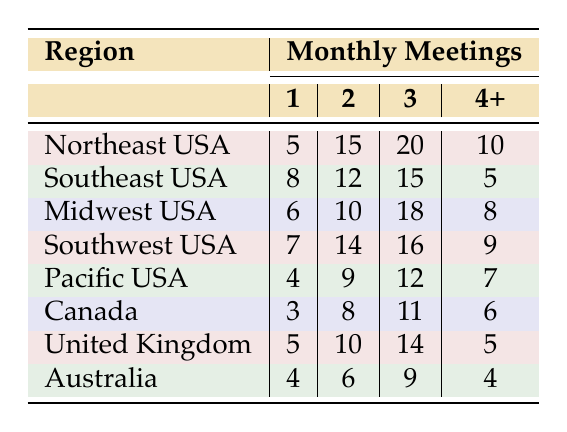What region has the highest number of readers participating in 3 meetings per month? The table shows that the Midwest USA has 18 participants attending 3 meetings, which is higher than any other region listed.
Answer: Midwest USA How many participants in the Northeast USA attend 2 meetings per month? According to the table, the participants in the Northeast USA attending 2 meetings are 15.
Answer: 15 Which region has the lowest participation for meetings held 4 or more times a month? Upon reviewing the table, the Southeast USA has the lowest number of participants, with only 5 attending 4 or more meetings.
Answer: Southeast USA What is the total number of readers in the Midwest USA? To find the total, we add the number of participants for all meeting frequencies in the Midwest USA: 6 (1) + 10 (2) + 18 (3) + 8 (4+) = 42.
Answer: 42 Is it true that Canada has more participants for 3 meetings than the Pacific USA? Yes, Canada has 11 participants for 3 meetings, while the Pacific USA has only 12, making the statement incorrect, so it’s false.
Answer: False Which region has the second highest attendance for meetings held 1 time per month? The Northeast USA has 5 participants, while the Southeast USA has 8. Thus, the Northeast USA comes in second after the Southeast USA for meetings held 1 time per month.
Answer: Northeast USA What is the average attendance for 2 meetings across all regions? We calculate the sum of participants for 2 meetings across all regions: 15 (Northeast) + 12 (Southeast) + 10 (Midwest) + 14 (Southwest) + 9 (Pacific) + 8 (Canada) + 10 (UK) + 6 (Australia) = 84. With 8 regions, the average is 84/8 = 10.5.
Answer: 10.5 How many total participants across all regions attend 1 meeting per month? To find the total, we sum the first column of participants from all regions: 5 (Northeast) + 8 (Southeast) + 6 (Midwest) + 7 (Southwest) + 4 (Pacific) + 3 (Canada) + 5 (UK) + 4 (Australia) = 38.
Answer: 38 